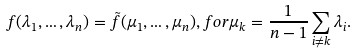Convert formula to latex. <formula><loc_0><loc_0><loc_500><loc_500>f ( \lambda _ { 1 } , \dots , \lambda _ { n } ) = \tilde { f } ( \mu _ { 1 } , \dots , \mu _ { n } ) , f o r \mu _ { k } = \frac { 1 } { n - 1 } \sum _ { i \ne k } \lambda _ { i } .</formula> 